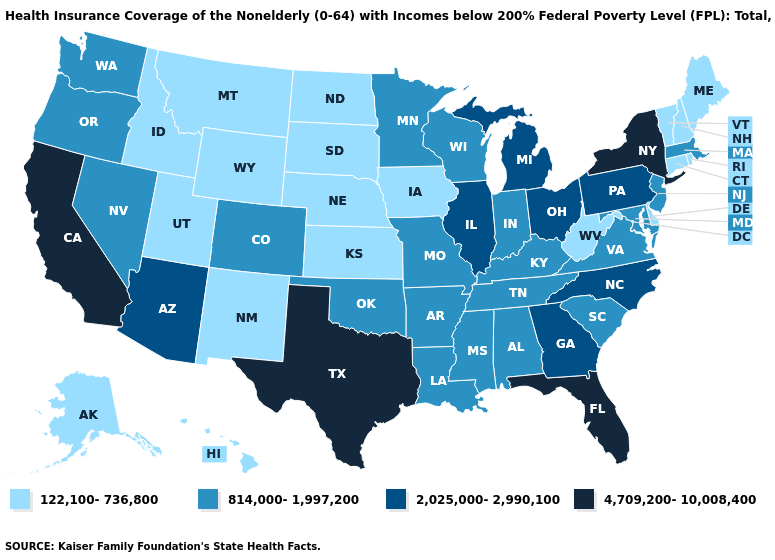Does Idaho have the lowest value in the USA?
Write a very short answer. Yes. Does Texas have the highest value in the USA?
Give a very brief answer. Yes. Name the states that have a value in the range 122,100-736,800?
Quick response, please. Alaska, Connecticut, Delaware, Hawaii, Idaho, Iowa, Kansas, Maine, Montana, Nebraska, New Hampshire, New Mexico, North Dakota, Rhode Island, South Dakota, Utah, Vermont, West Virginia, Wyoming. Name the states that have a value in the range 2,025,000-2,990,100?
Quick response, please. Arizona, Georgia, Illinois, Michigan, North Carolina, Ohio, Pennsylvania. What is the lowest value in the USA?
Be succinct. 122,100-736,800. Does New Jersey have the lowest value in the Northeast?
Give a very brief answer. No. What is the highest value in the South ?
Answer briefly. 4,709,200-10,008,400. Does Indiana have the lowest value in the MidWest?
Be succinct. No. Among the states that border Oklahoma , which have the lowest value?
Answer briefly. Kansas, New Mexico. Does Florida have the highest value in the USA?
Answer briefly. Yes. Among the states that border Rhode Island , which have the lowest value?
Be succinct. Connecticut. Name the states that have a value in the range 122,100-736,800?
Quick response, please. Alaska, Connecticut, Delaware, Hawaii, Idaho, Iowa, Kansas, Maine, Montana, Nebraska, New Hampshire, New Mexico, North Dakota, Rhode Island, South Dakota, Utah, Vermont, West Virginia, Wyoming. What is the value of Utah?
Answer briefly. 122,100-736,800. What is the lowest value in the USA?
Answer briefly. 122,100-736,800. What is the highest value in the USA?
Concise answer only. 4,709,200-10,008,400. 